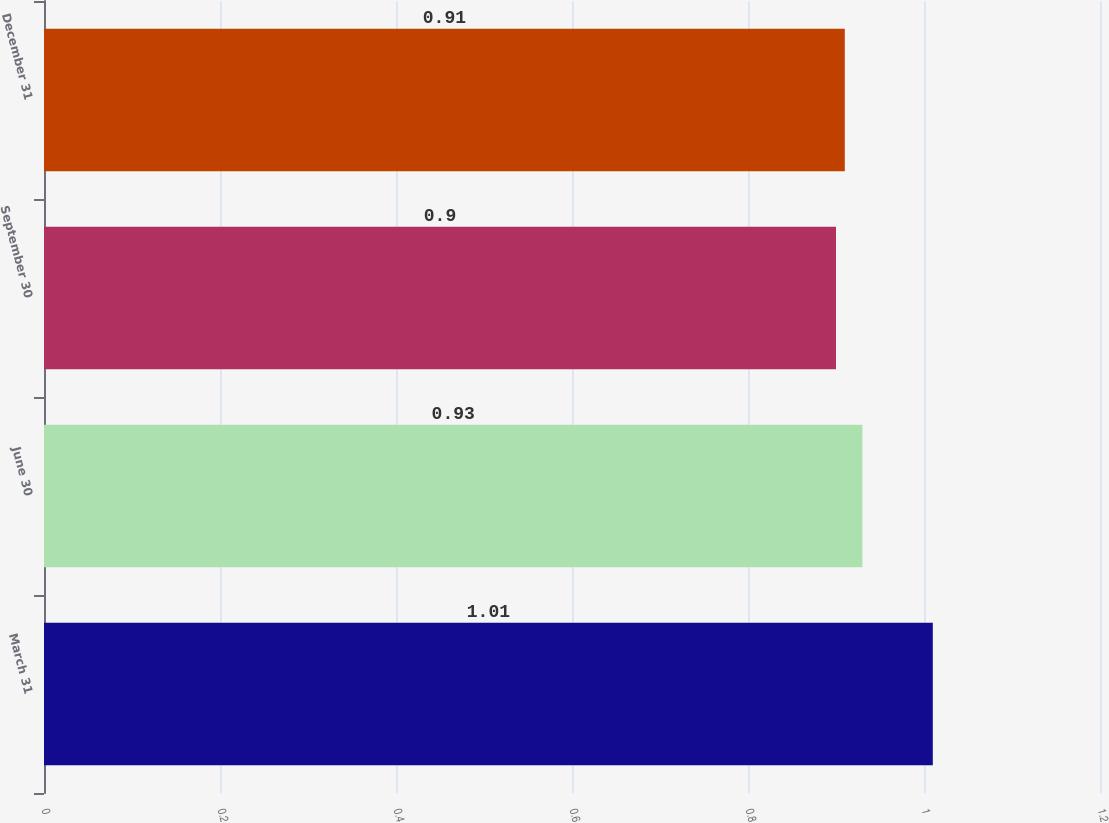<chart> <loc_0><loc_0><loc_500><loc_500><bar_chart><fcel>March 31<fcel>June 30<fcel>September 30<fcel>December 31<nl><fcel>1.01<fcel>0.93<fcel>0.9<fcel>0.91<nl></chart> 